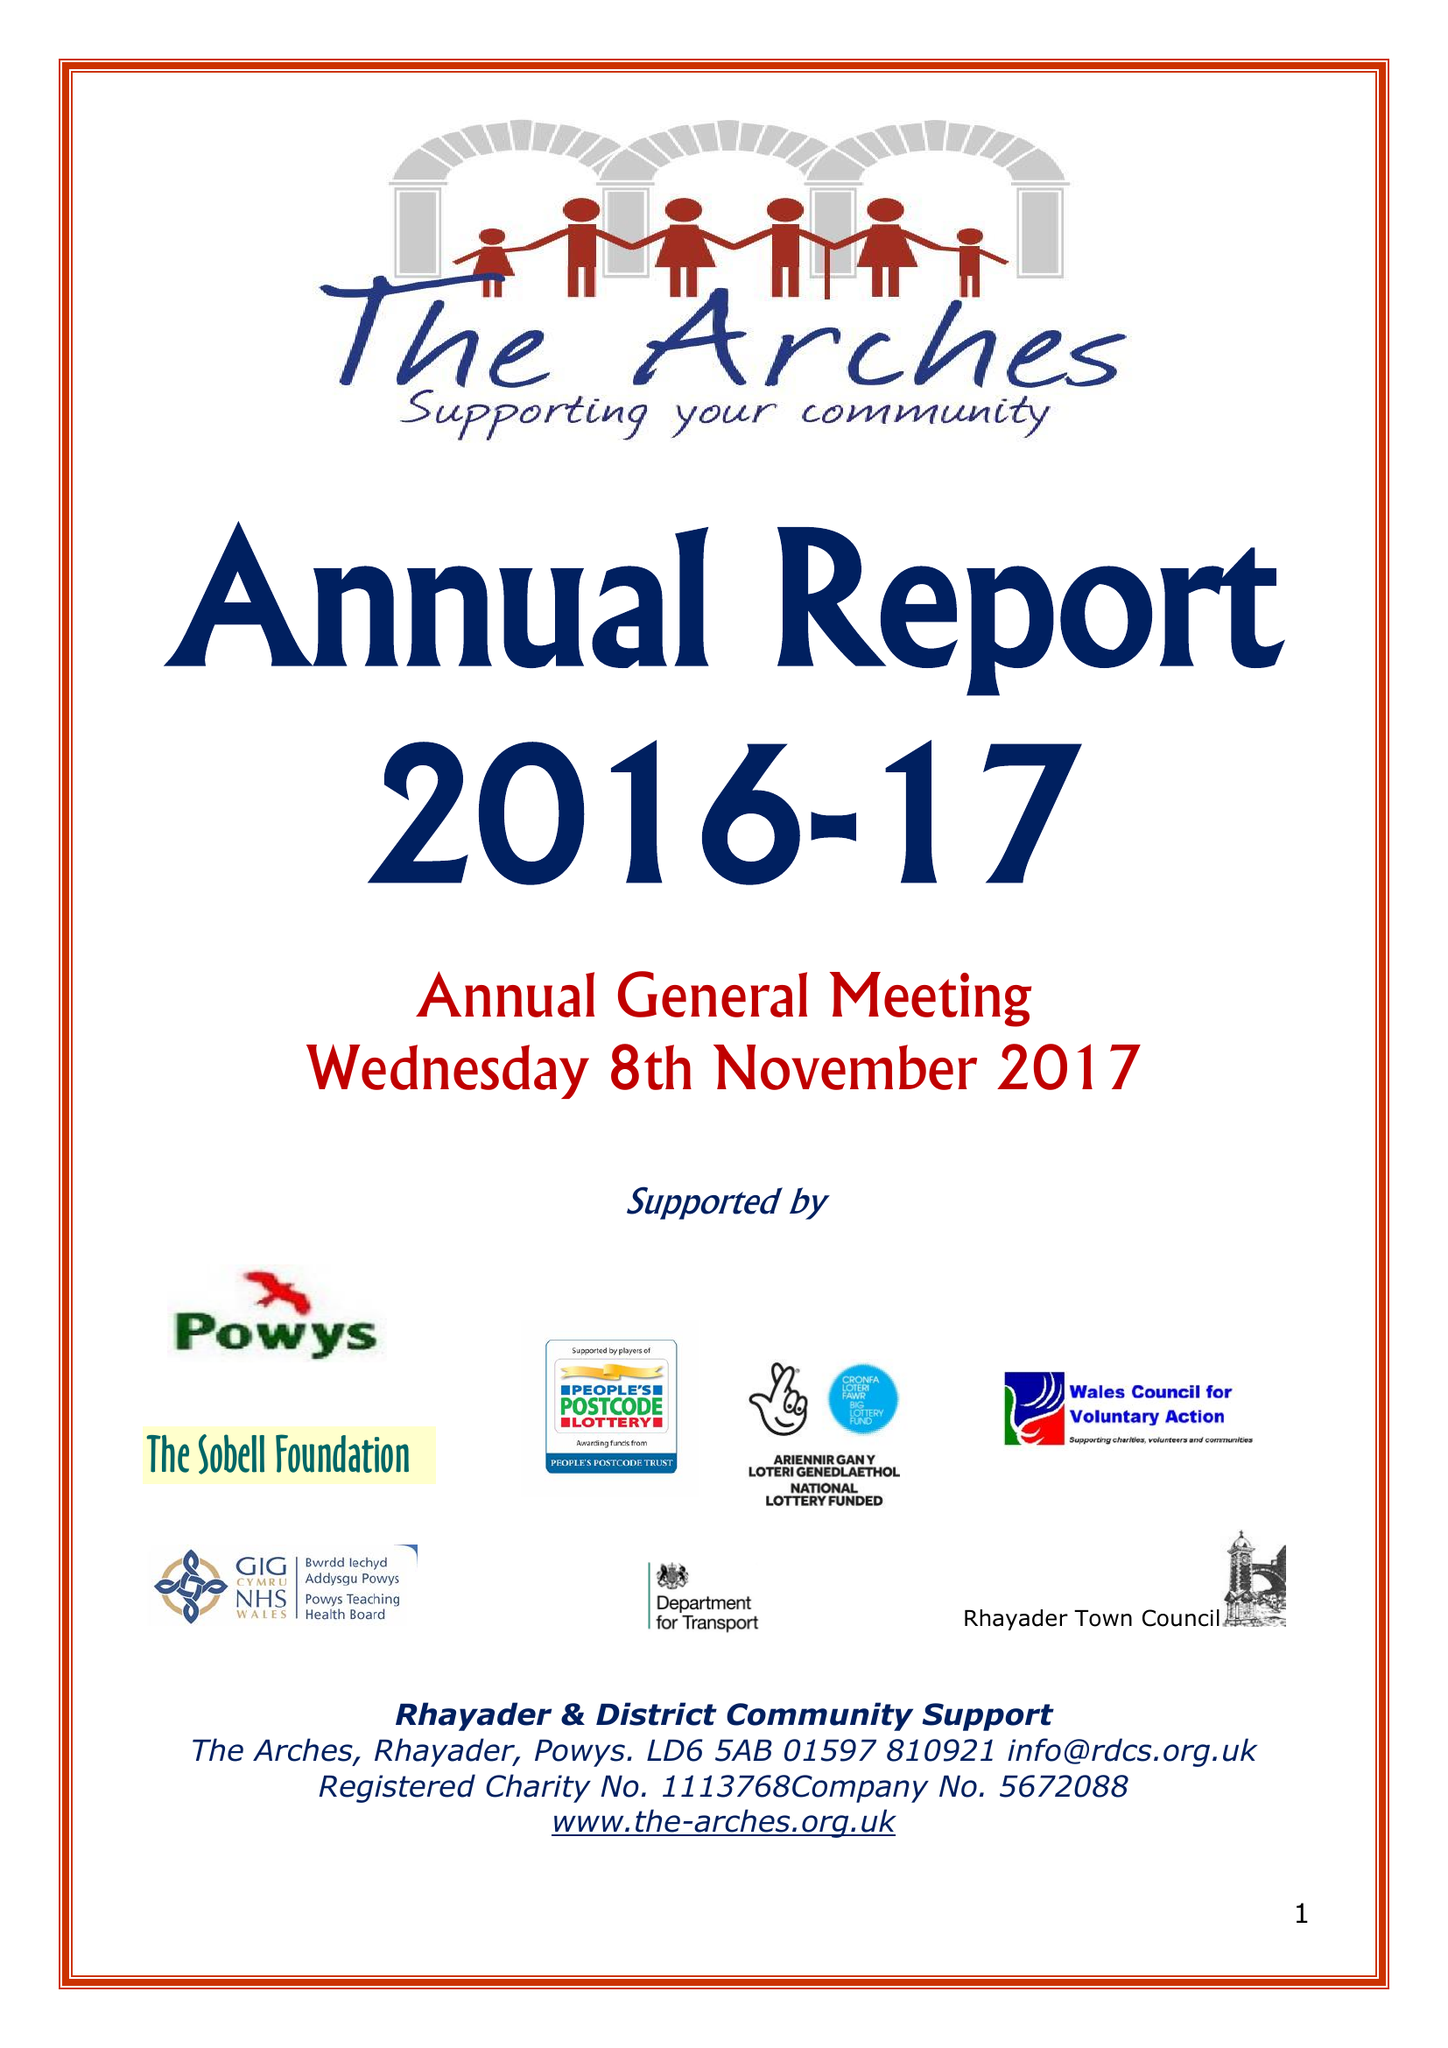What is the value for the report_date?
Answer the question using a single word or phrase. 2017-03-31 